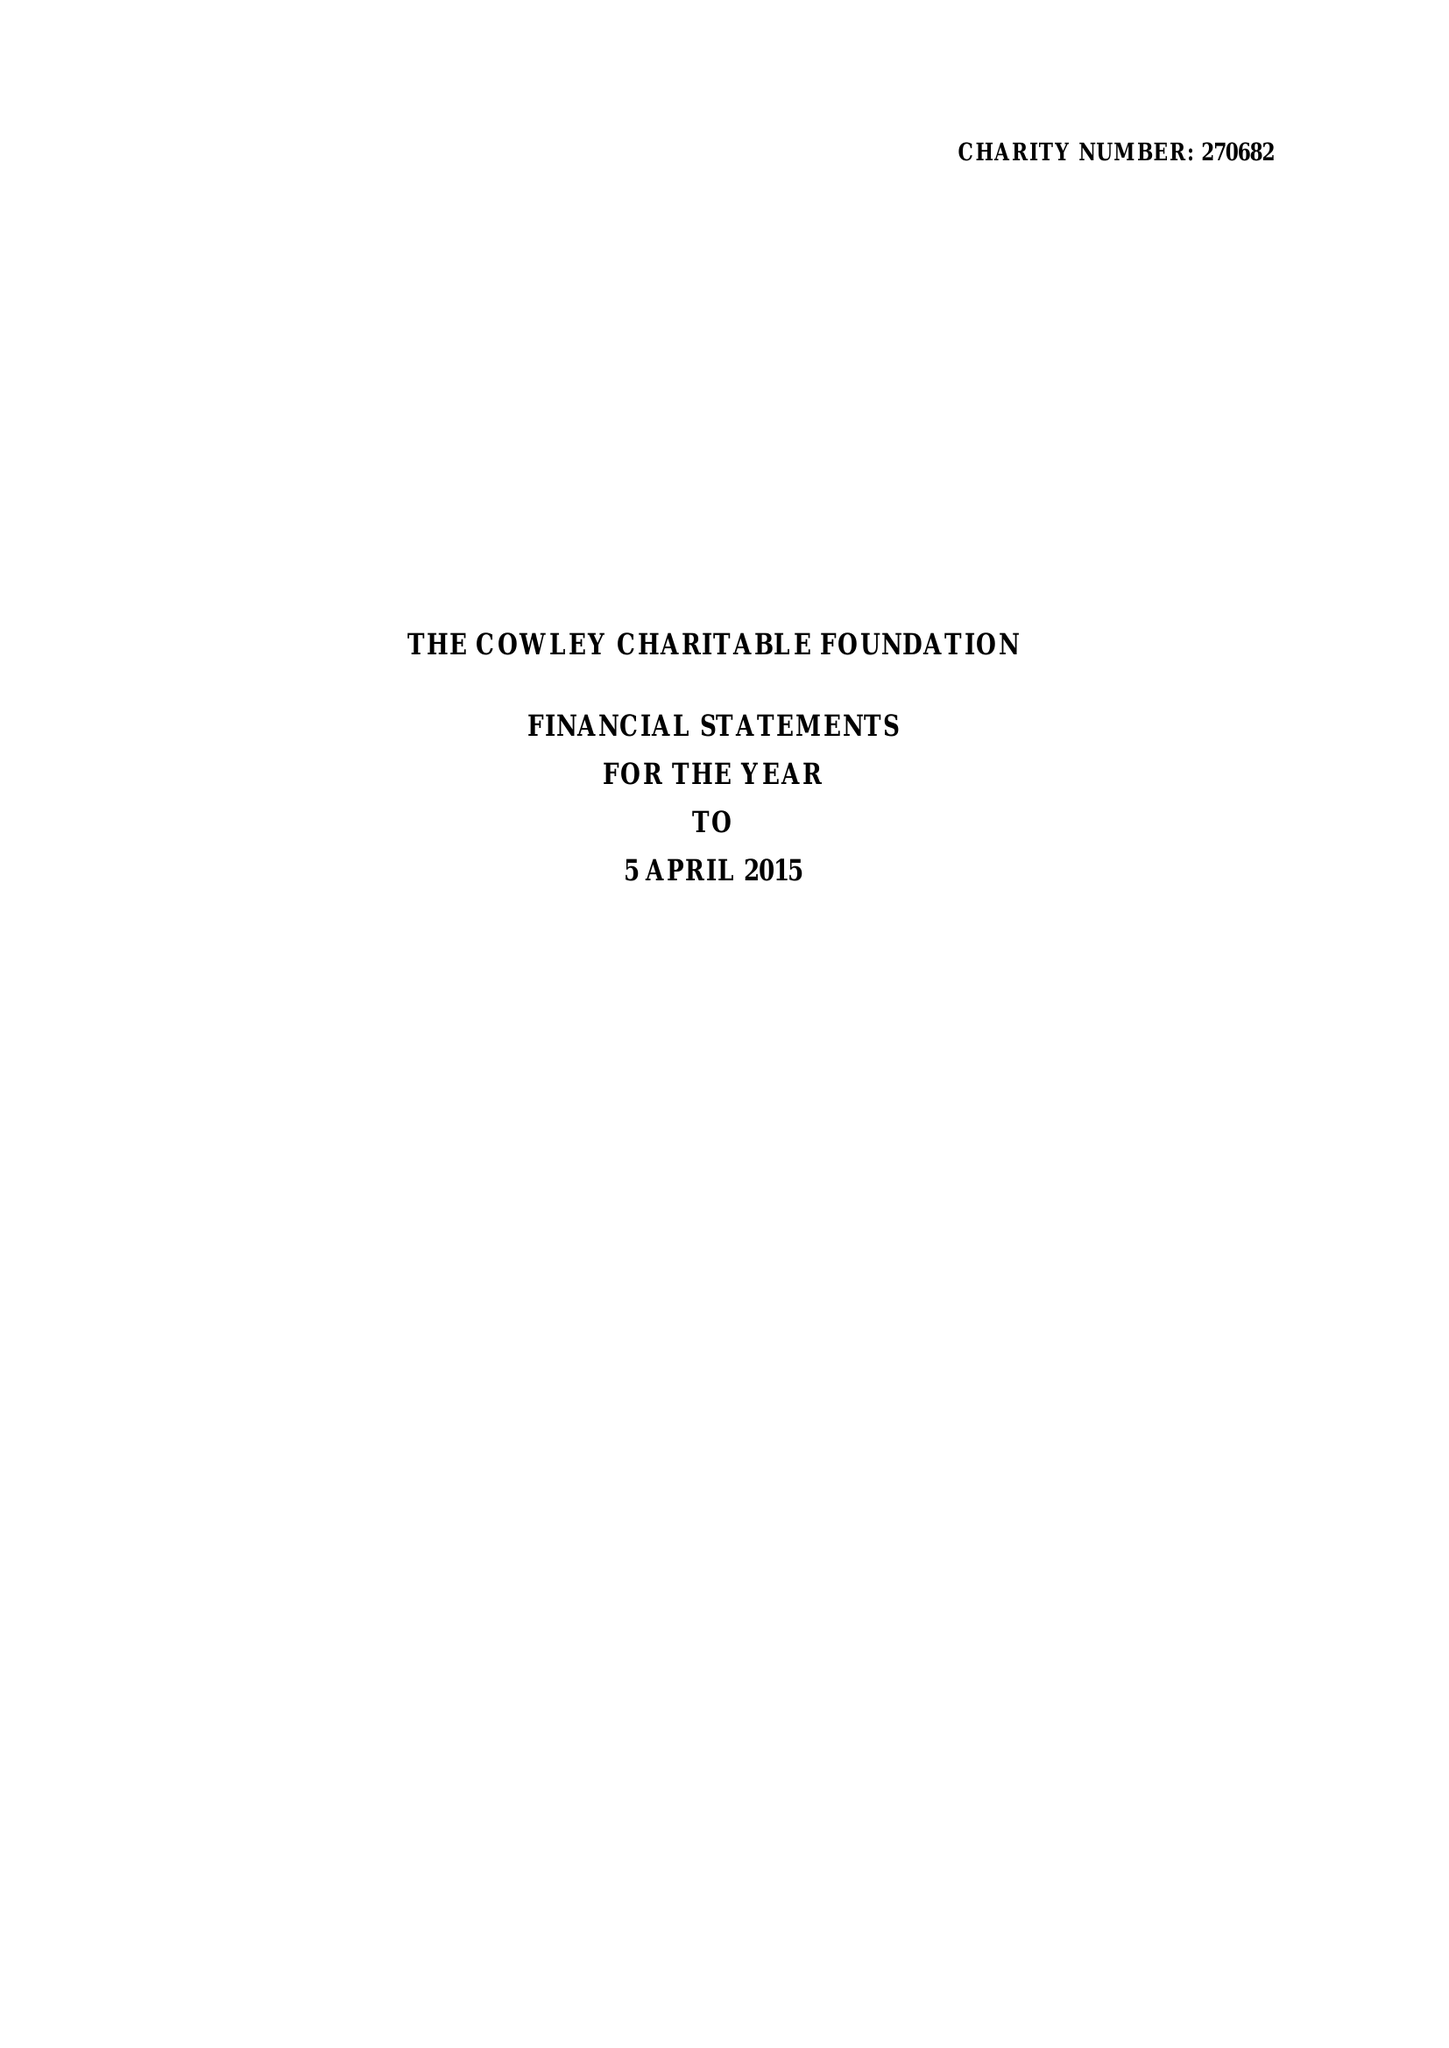What is the value for the charity_name?
Answer the question using a single word or phrase. The Cowley Charitable Foundation 